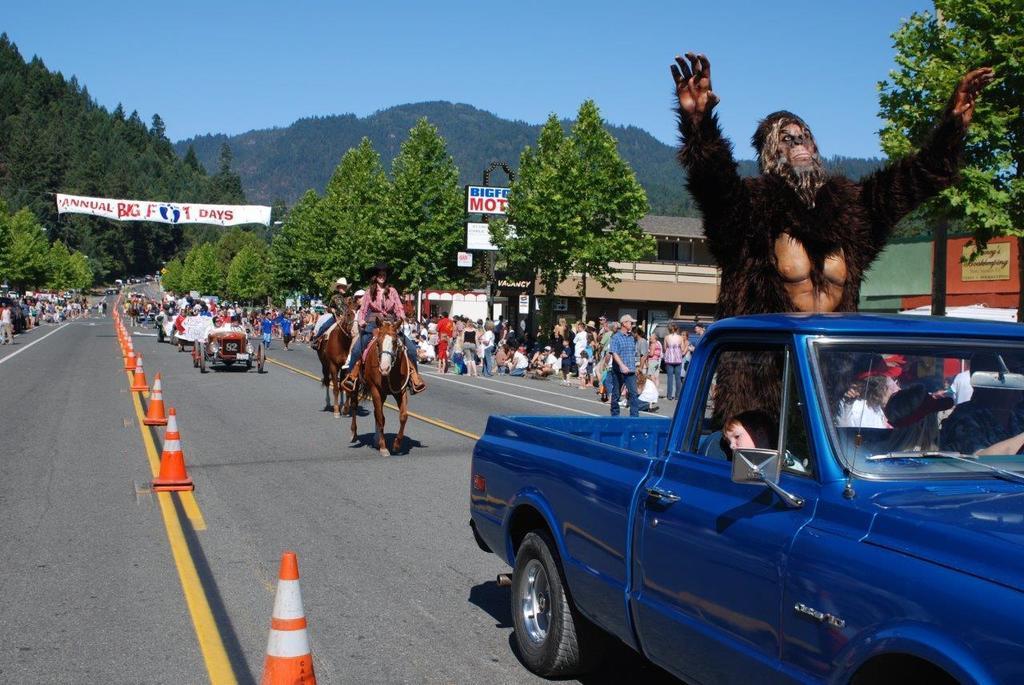In one or two sentences, can you explain what this image depicts? In this image I can see few trees, traffic cones, buildings, group of people, boards, few vehicles and few people are sitting on the horses. In front I can see one person is wearing different costume and few people inside the vehicle. The sky is in blue color. 